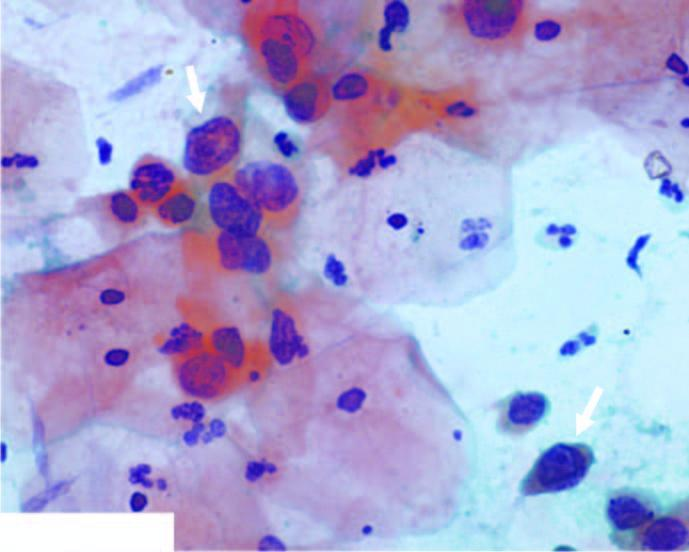what shows numerous pmns?
Answer the question using a single word or phrase. The background 